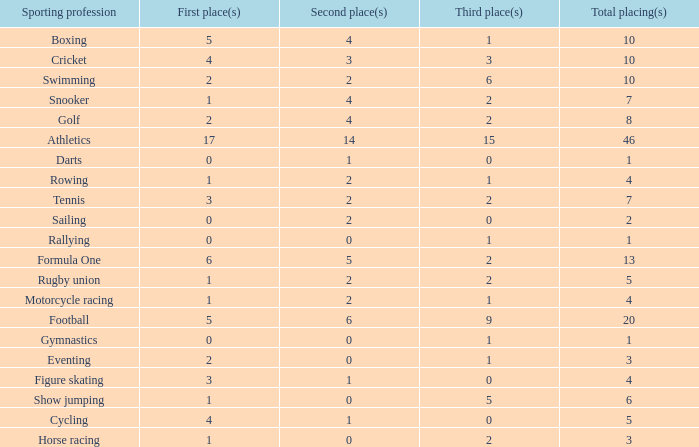How many second place showings does snooker have? 4.0. 